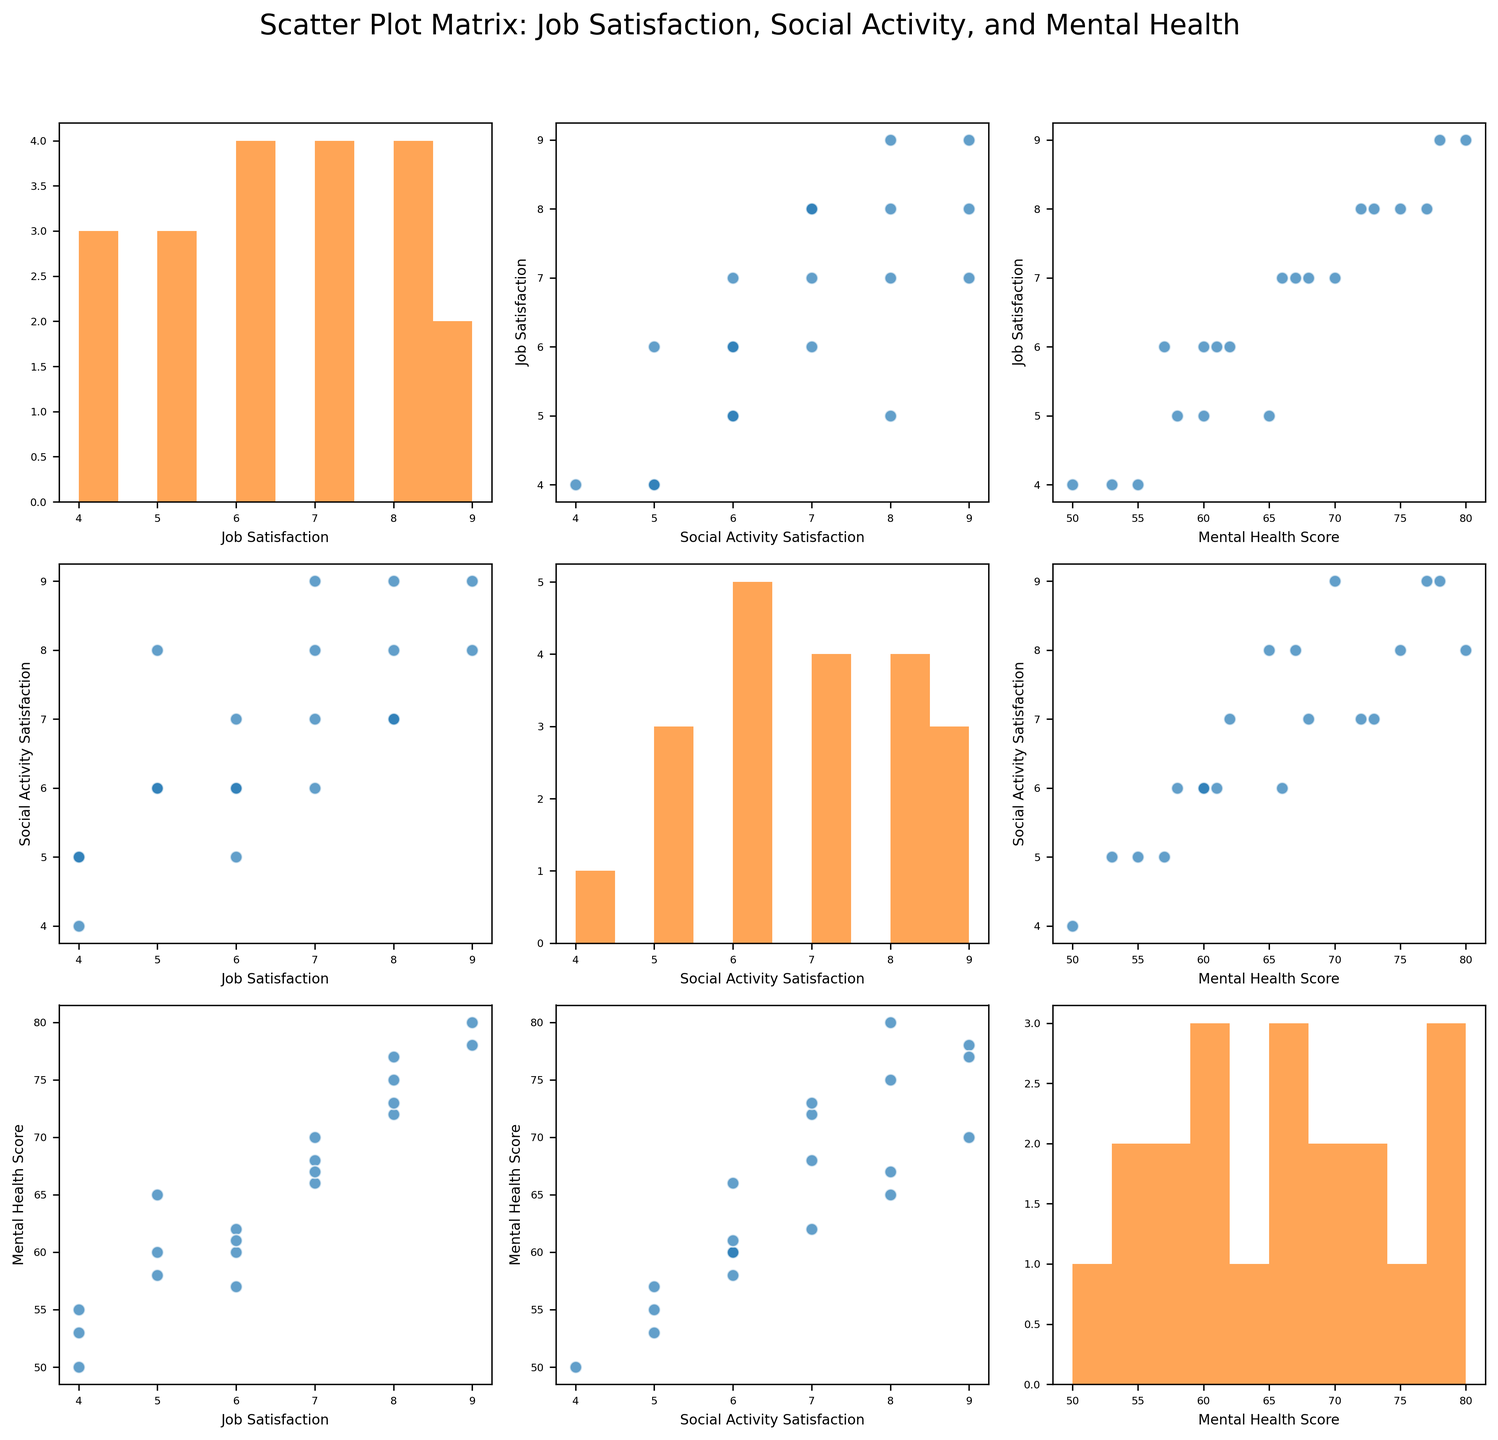What is the title of the figure? The title of the figure is displayed at the top, usually in larger and bold font, to provide a summary of the content.
Answer: Scatter Plot Matrix: Job Satisfaction, Social Activity, and Mental Health How many variables are shown in the figure? You can determine the number of variables by counting the number of different axes or plots along one row or column in the figure.
Answer: Three variables What color is used for the scatter points in the scatter plots? By observing the scatter plots carefully, we can see that all the scatter points have the same blue color.
Answer: Blue What type of plot is used on the diagonal of the scatter plot matrix? The diagonal of the scatter plot matrix displays histograms, as indicated by the bars recorded along the diagonal elements.
Answer: Histograms Which axis represents mental health score in the scatter plot between job satisfaction and mental health score? By looking at the scatter plot between job satisfaction and mental health score, we can see that mental health score is represented along the x-axis.
Answer: X-axis What's the average job satisfaction for the entire dataset? To calculate the average, sum all the job satisfaction values and divide by the number of students. (8+5+7+6+9+4+7+6+8+5+9+4+6+7+8+5+6+7+8+4)/20 = 6.5
Answer: 6.5 What is the relationship between social activity satisfaction and job satisfaction as shown in the scatter plot? Analyzing the scatter plot between social activity satisfaction and job satisfaction, we can see if there appears to be a positive trend, indicating that higher social activity satisfaction tends to correlate with higher job satisfaction.
Answer: Positive correlation Which variable appears to have the largest range of values? By observing the histograms on the diagonal, compare the distribution spans. Mental health score ranges from about 50 to 80. Job and social activity satisfaction have ranges from 4 to 9. Therefore, mental health score has a broader range.
Answer: Mental health score How many students have a job satisfaction score of 8? By examining the histogram for job satisfaction, count the frequency for the score of 8.
Answer: Four Is there any indication of a relationship between mental health scores and social activity satisfaction? By observing the scatter plot between mental health scores and social activity satisfaction, we can determine if there seems to be any observable trend, like a positive correlation.
Answer: Positive correlation 